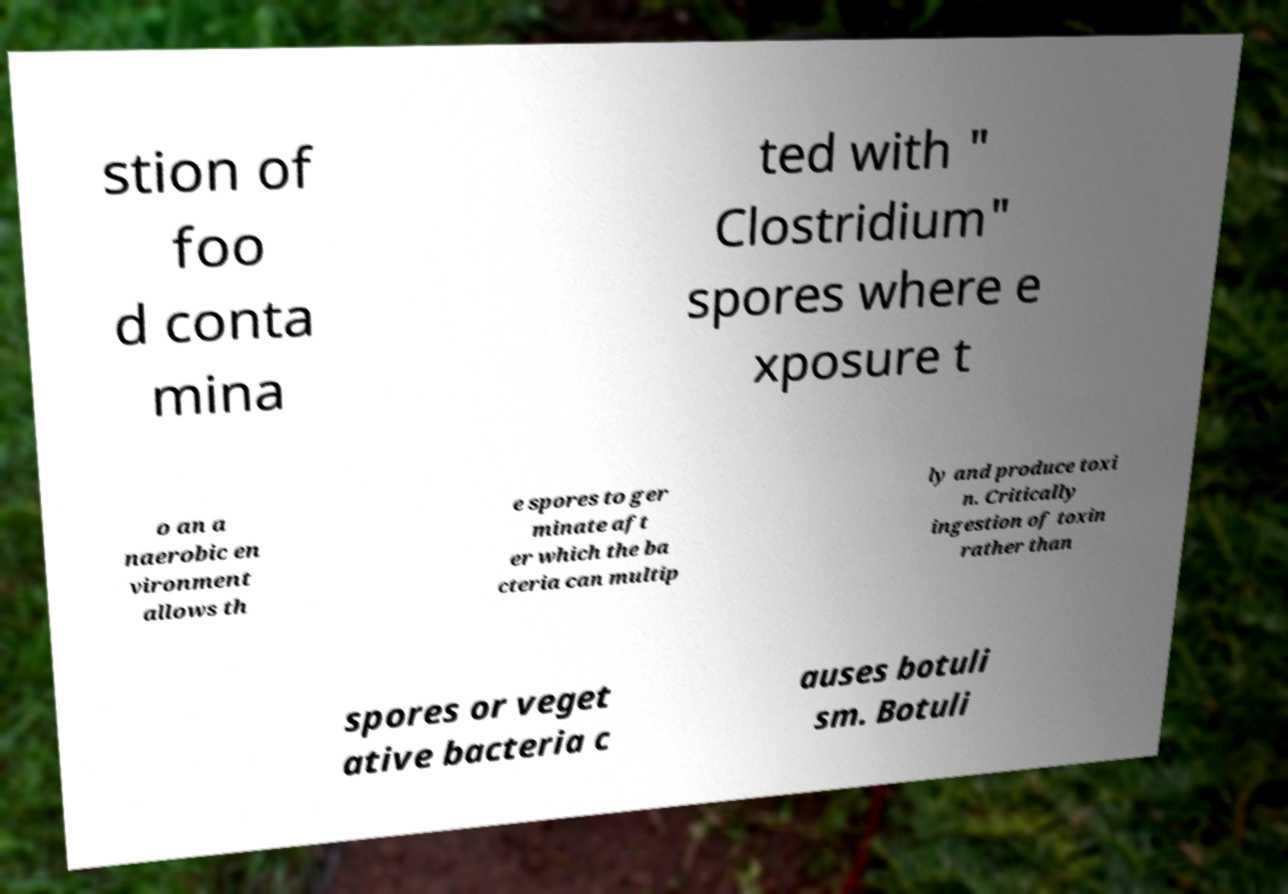What messages or text are displayed in this image? I need them in a readable, typed format. stion of foo d conta mina ted with " Clostridium" spores where e xposure t o an a naerobic en vironment allows th e spores to ger minate aft er which the ba cteria can multip ly and produce toxi n. Critically ingestion of toxin rather than spores or veget ative bacteria c auses botuli sm. Botuli 